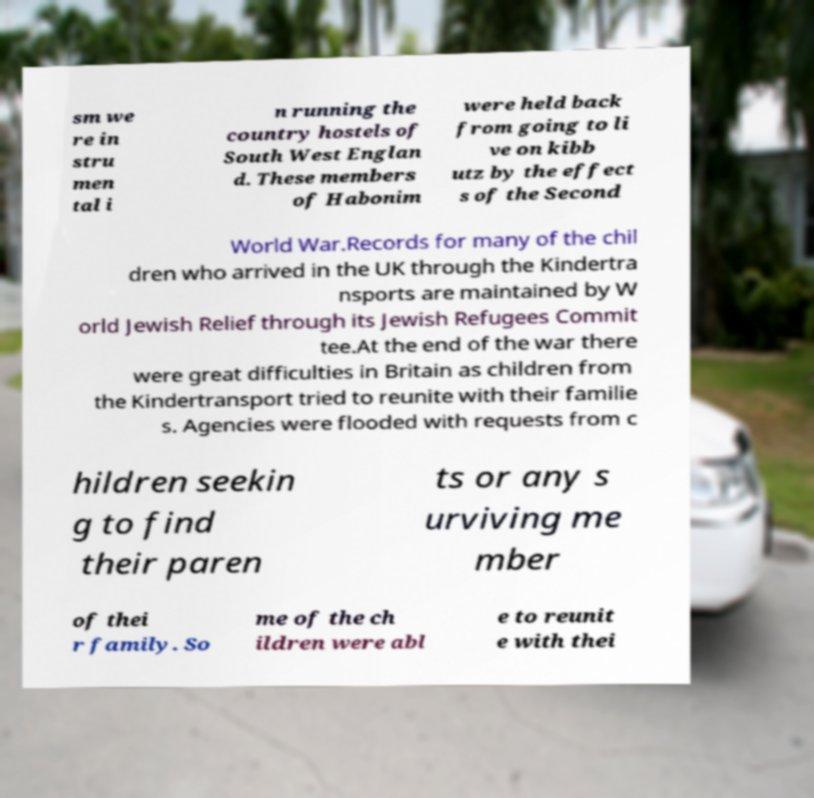Please identify and transcribe the text found in this image. sm we re in stru men tal i n running the country hostels of South West Englan d. These members of Habonim were held back from going to li ve on kibb utz by the effect s of the Second World War.Records for many of the chil dren who arrived in the UK through the Kindertra nsports are maintained by W orld Jewish Relief through its Jewish Refugees Commit tee.At the end of the war there were great difficulties in Britain as children from the Kindertransport tried to reunite with their familie s. Agencies were flooded with requests from c hildren seekin g to find their paren ts or any s urviving me mber of thei r family. So me of the ch ildren were abl e to reunit e with thei 